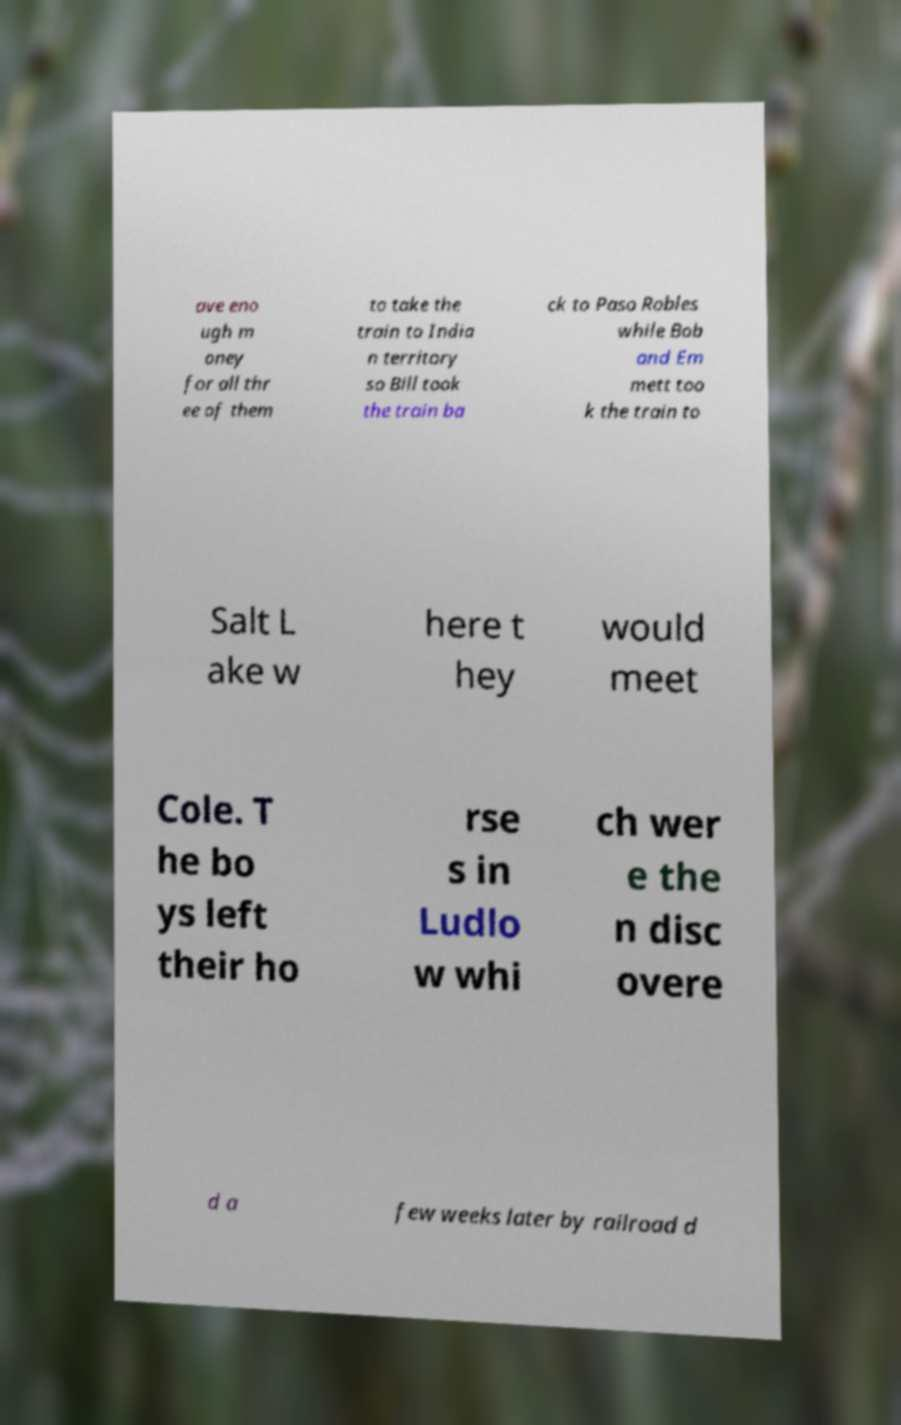Please read and relay the text visible in this image. What does it say? ave eno ugh m oney for all thr ee of them to take the train to India n territory so Bill took the train ba ck to Paso Robles while Bob and Em mett too k the train to Salt L ake w here t hey would meet Cole. T he bo ys left their ho rse s in Ludlo w whi ch wer e the n disc overe d a few weeks later by railroad d 